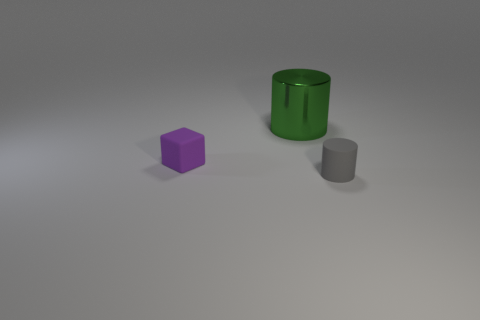Add 1 gray rubber objects. How many objects exist? 4 Subtract all cylinders. How many objects are left? 1 Subtract 1 purple cubes. How many objects are left? 2 Subtract all metallic objects. Subtract all tiny matte objects. How many objects are left? 0 Add 1 big green metal cylinders. How many big green metal cylinders are left? 2 Add 2 big gray matte things. How many big gray matte things exist? 2 